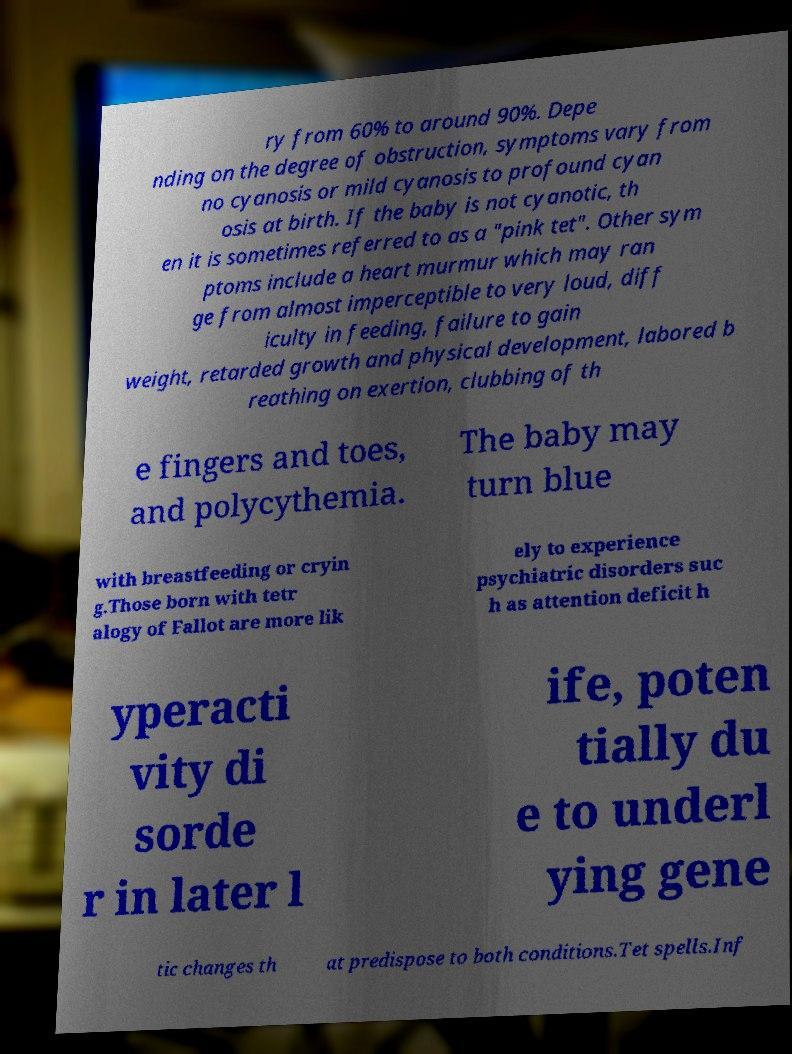There's text embedded in this image that I need extracted. Can you transcribe it verbatim? ry from 60% to around 90%. Depe nding on the degree of obstruction, symptoms vary from no cyanosis or mild cyanosis to profound cyan osis at birth. If the baby is not cyanotic, th en it is sometimes referred to as a "pink tet". Other sym ptoms include a heart murmur which may ran ge from almost imperceptible to very loud, diff iculty in feeding, failure to gain weight, retarded growth and physical development, labored b reathing on exertion, clubbing of th e fingers and toes, and polycythemia. The baby may turn blue with breastfeeding or cryin g.Those born with tetr alogy of Fallot are more lik ely to experience psychiatric disorders suc h as attention deficit h yperacti vity di sorde r in later l ife, poten tially du e to underl ying gene tic changes th at predispose to both conditions.Tet spells.Inf 